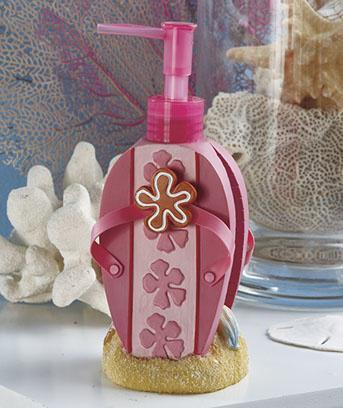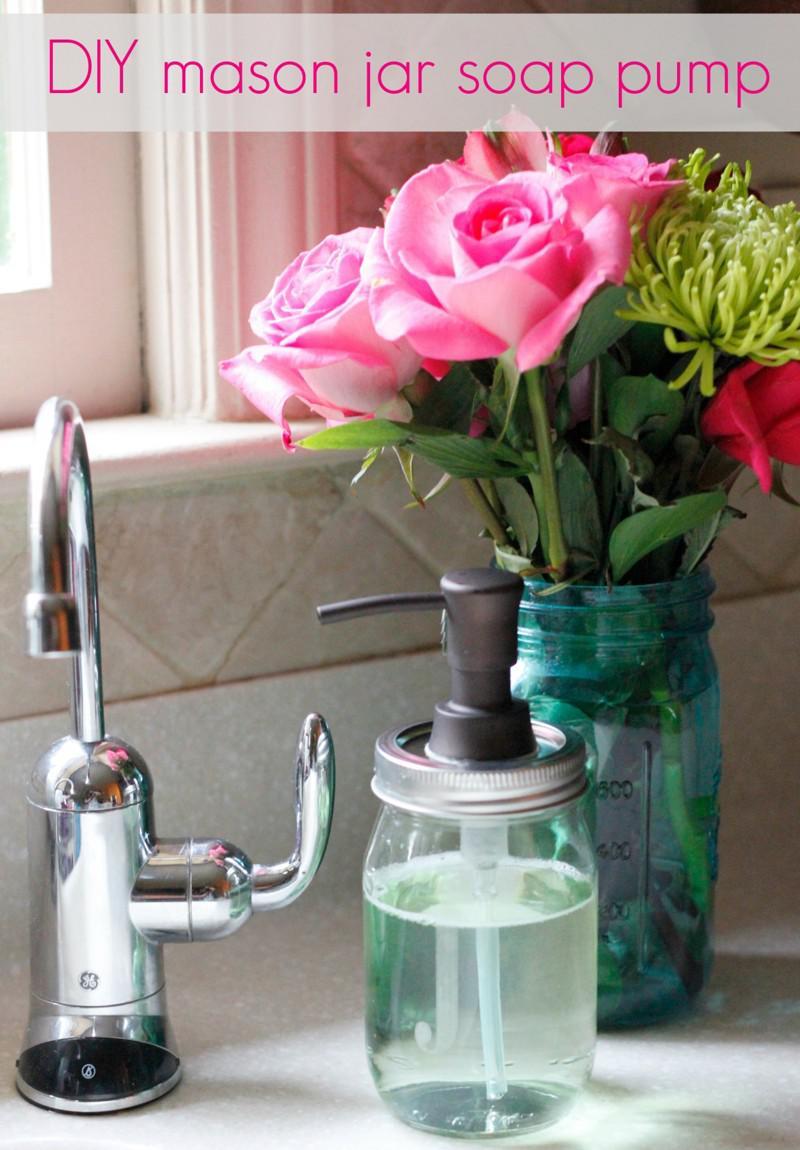The first image is the image on the left, the second image is the image on the right. Considering the images on both sides, is "The image on the right has pink flowers inside of a vase." valid? Answer yes or no. Yes. 